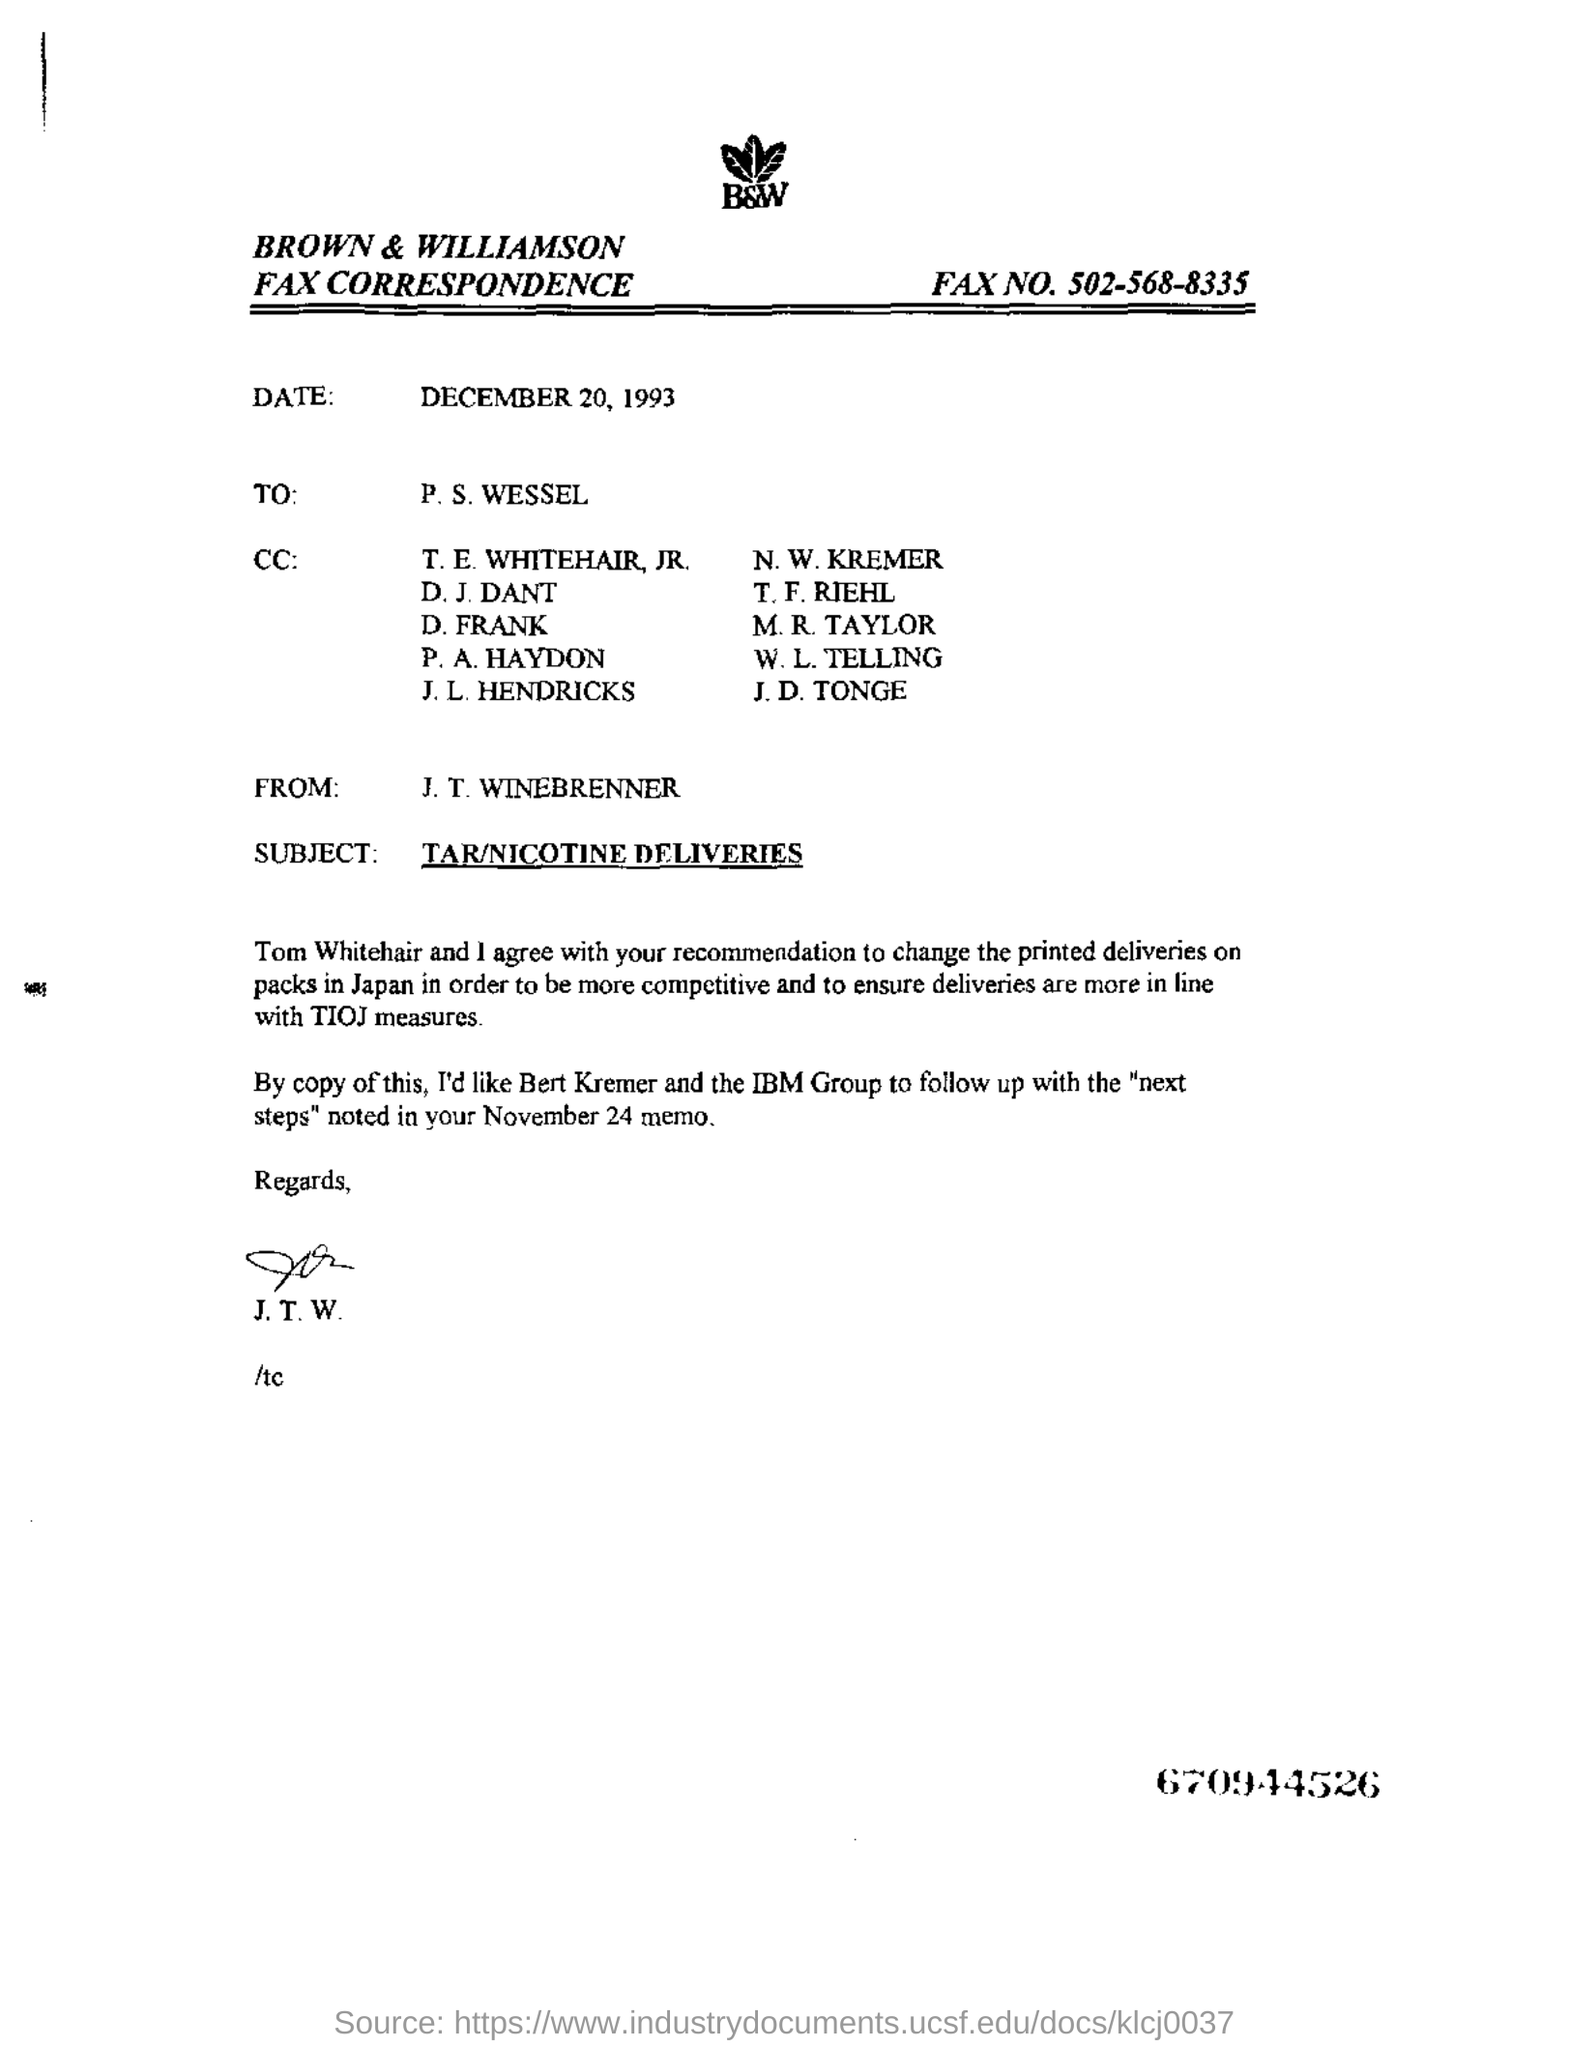Identify some key points in this picture. The subject of the email is TAR/NICOTINE DELIVERIES. The date mentioned is December 20, 1993. The person whose name is in the "FROM" field is J. T. WINEBRENNER. 